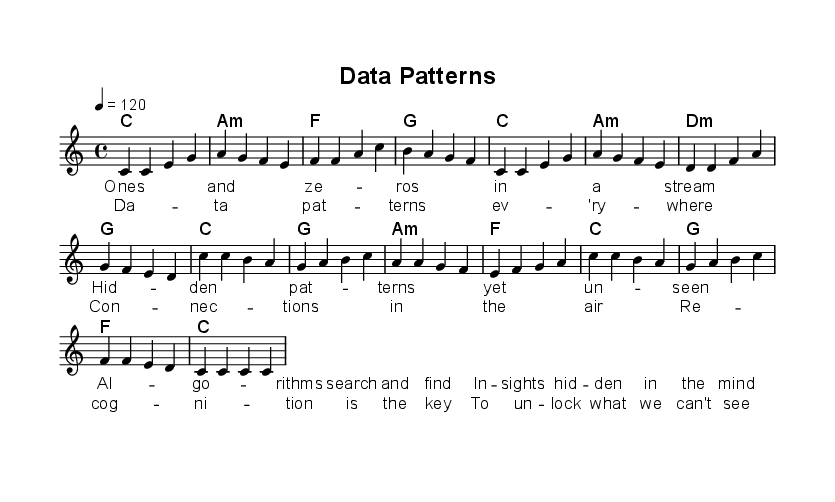What is the key signature of this music? The key signature indicated at the beginning of the score is C major, which has no sharps or flats.
Answer: C major What is the time signature of the piece? The time signature shown at the beginning of the score is 4/4, which means there are four beats in each measure.
Answer: 4/4 What is the tempo marking of the music? The tempo marking specified in the music is 4 = 120, indicating that there are 120 beats per minute.
Answer: 120 How many measures are in the chorus section? The chorus section consists of 8 measures, counted from the beginning of the chorus to the end.
Answer: 8 Which chord follows the first measure of the verse? The first measure of the verse is a C major chord, as indicated in the harmony section of the score.
Answer: C What is the lyrical theme of the song? The lyrics focus on concepts of data analysis and pattern recognition, revealed in the provided verse and chorus lyrics.
Answer: Data analysis How many distinct chords are used in the chorus? The distinct chords in the chorus are C, G, A minor, and F, totaling four unique chords.
Answer: 4 